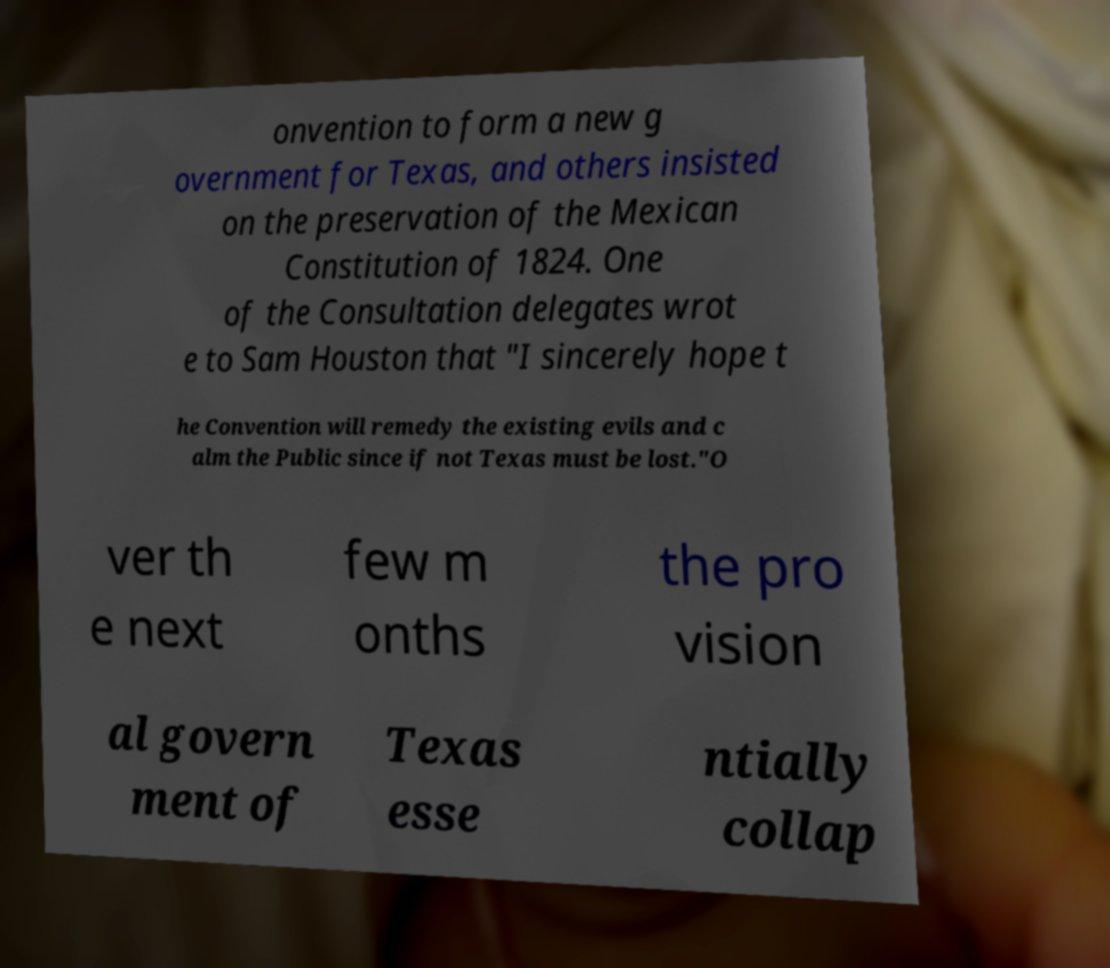Could you assist in decoding the text presented in this image and type it out clearly? onvention to form a new g overnment for Texas, and others insisted on the preservation of the Mexican Constitution of 1824. One of the Consultation delegates wrot e to Sam Houston that "I sincerely hope t he Convention will remedy the existing evils and c alm the Public since if not Texas must be lost."O ver th e next few m onths the pro vision al govern ment of Texas esse ntially collap 